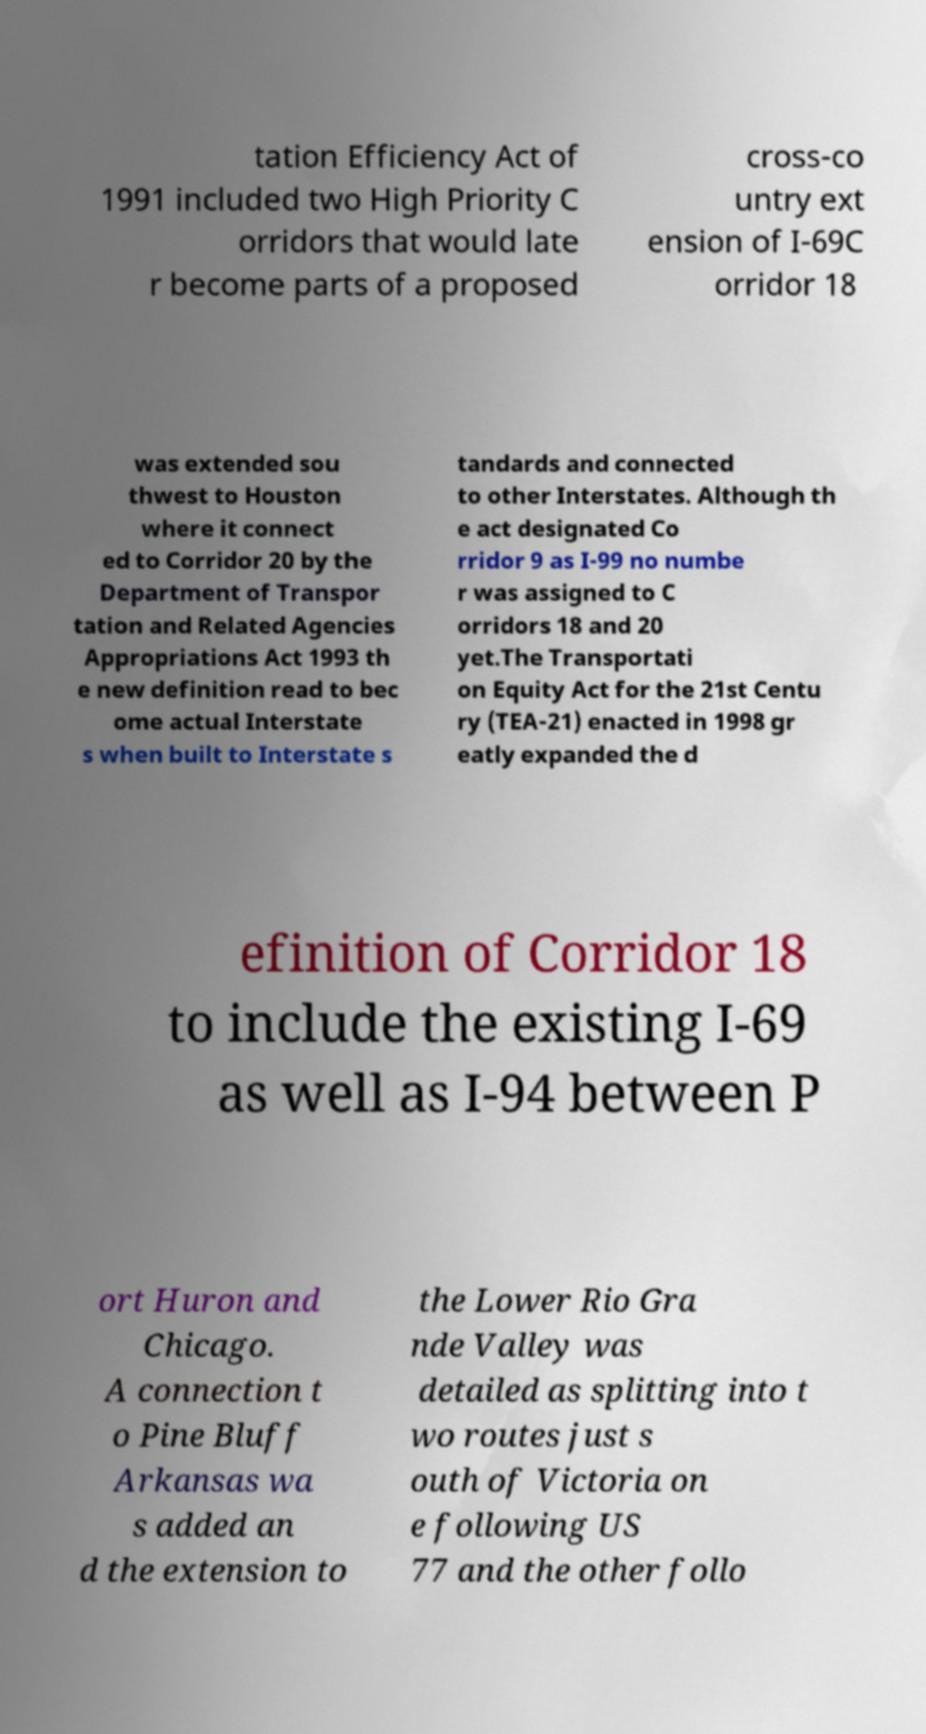There's text embedded in this image that I need extracted. Can you transcribe it verbatim? tation Efficiency Act of 1991 included two High Priority C orridors that would late r become parts of a proposed cross-co untry ext ension of I-69C orridor 18 was extended sou thwest to Houston where it connect ed to Corridor 20 by the Department of Transpor tation and Related Agencies Appropriations Act 1993 th e new definition read to bec ome actual Interstate s when built to Interstate s tandards and connected to other Interstates. Although th e act designated Co rridor 9 as I-99 no numbe r was assigned to C orridors 18 and 20 yet.The Transportati on Equity Act for the 21st Centu ry (TEA-21) enacted in 1998 gr eatly expanded the d efinition of Corridor 18 to include the existing I-69 as well as I-94 between P ort Huron and Chicago. A connection t o Pine Bluff Arkansas wa s added an d the extension to the Lower Rio Gra nde Valley was detailed as splitting into t wo routes just s outh of Victoria on e following US 77 and the other follo 